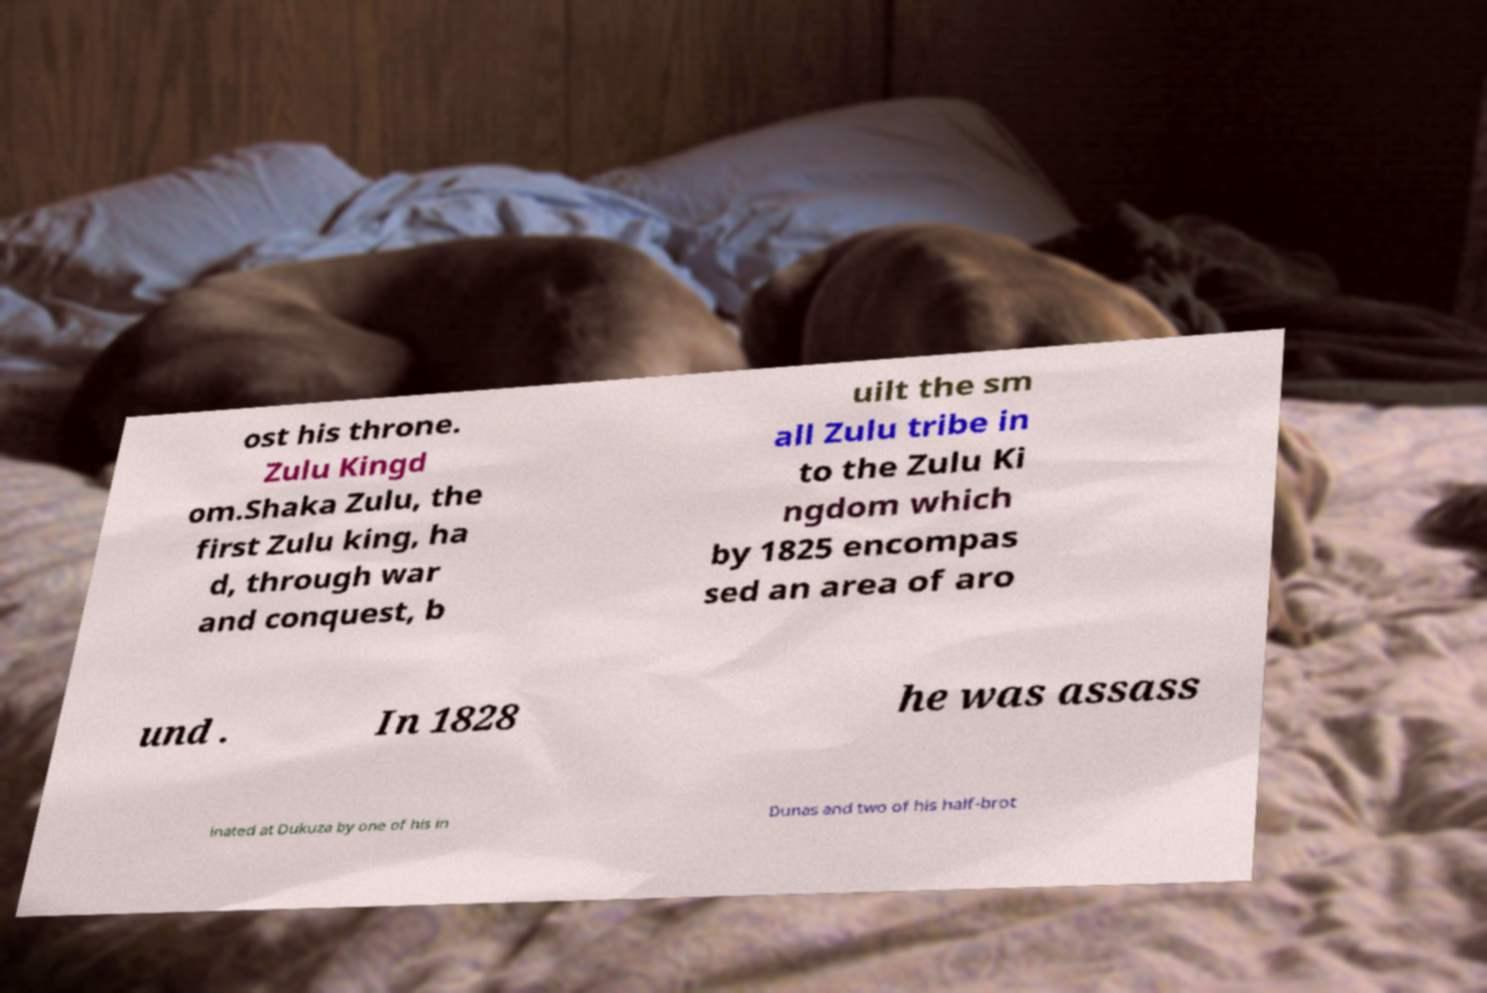What messages or text are displayed in this image? I need them in a readable, typed format. ost his throne. Zulu Kingd om.Shaka Zulu, the first Zulu king, ha d, through war and conquest, b uilt the sm all Zulu tribe in to the Zulu Ki ngdom which by 1825 encompas sed an area of aro und . In 1828 he was assass inated at Dukuza by one of his in Dunas and two of his half-brot 